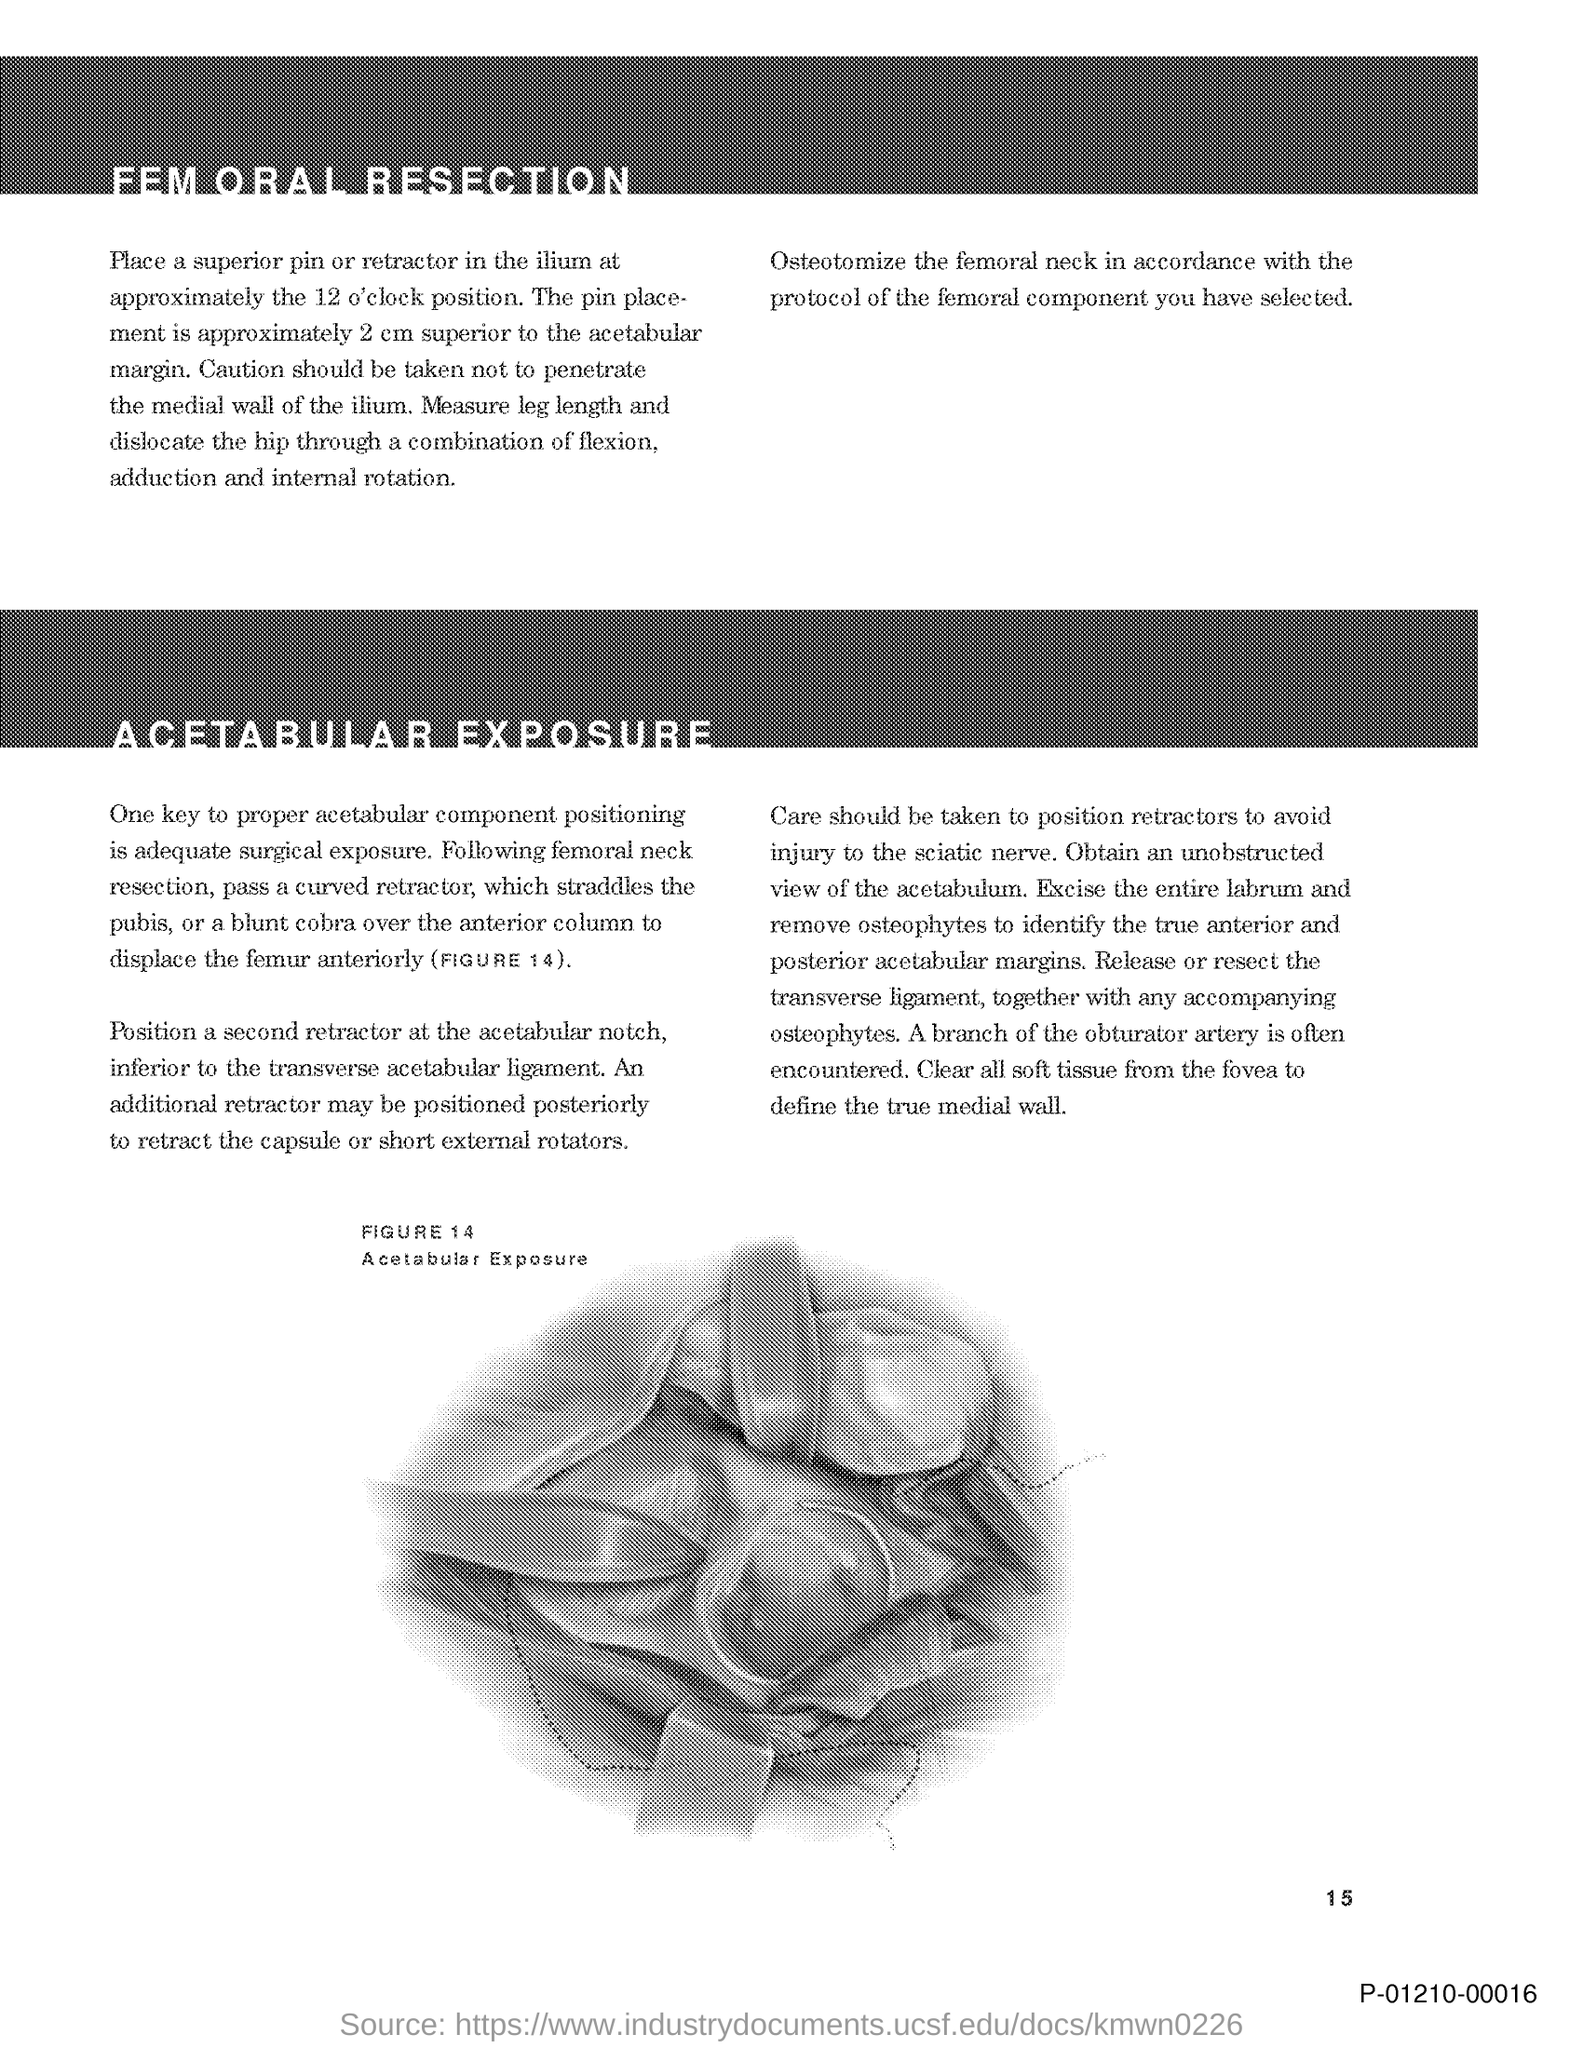What is the page no mentioned in this document?
 15 